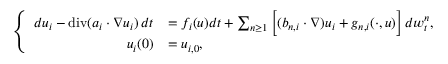Convert formula to latex. <formula><loc_0><loc_0><loc_500><loc_500>\left \{ \begin{array} { r l } { d u _ { i } - { d i v } ( a _ { i } \cdot \nabla u _ { i } ) \, d t } & { = f _ { i } ( u ) d t + \sum _ { n \geq 1 } \left [ ( b _ { n , i } \cdot \nabla ) u _ { i } + g _ { n , i } ( \cdot , u ) \right ] \, d w _ { t } ^ { n } , } \\ { u _ { i } ( 0 ) } & { = u _ { i , 0 } , } \end{array}</formula> 